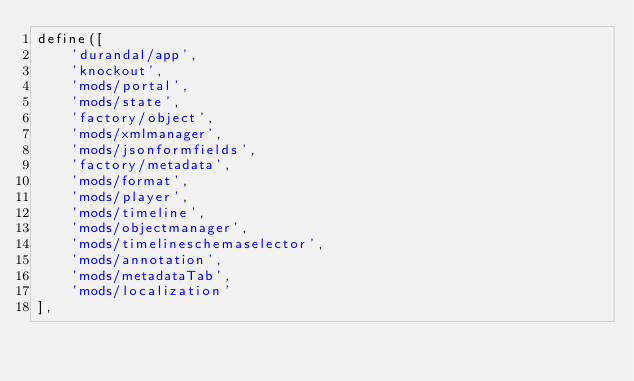Convert code to text. <code><loc_0><loc_0><loc_500><loc_500><_JavaScript_>define([
    'durandal/app',
    'knockout',
    'mods/portal',
    'mods/state',
    'factory/object',
    'mods/xmlmanager',
    'mods/jsonformfields',
    'factory/metadata',
    'mods/format',
    'mods/player',
    'mods/timeline',
    'mods/objectmanager',
    'mods/timelineschemaselector',
    'mods/annotation',
    'mods/metadataTab',
    'mods/localization'
],</code> 